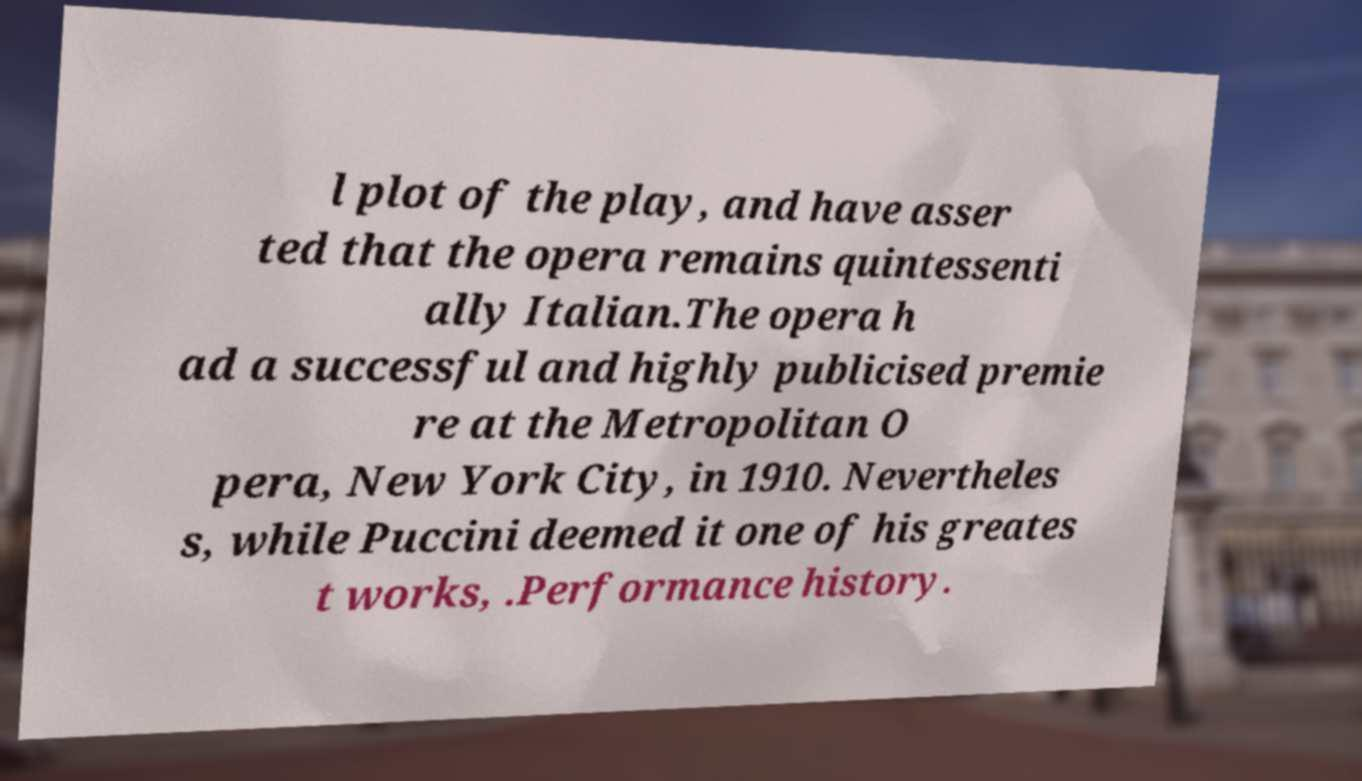Could you assist in decoding the text presented in this image and type it out clearly? l plot of the play, and have asser ted that the opera remains quintessenti ally Italian.The opera h ad a successful and highly publicised premie re at the Metropolitan O pera, New York City, in 1910. Nevertheles s, while Puccini deemed it one of his greates t works, .Performance history. 